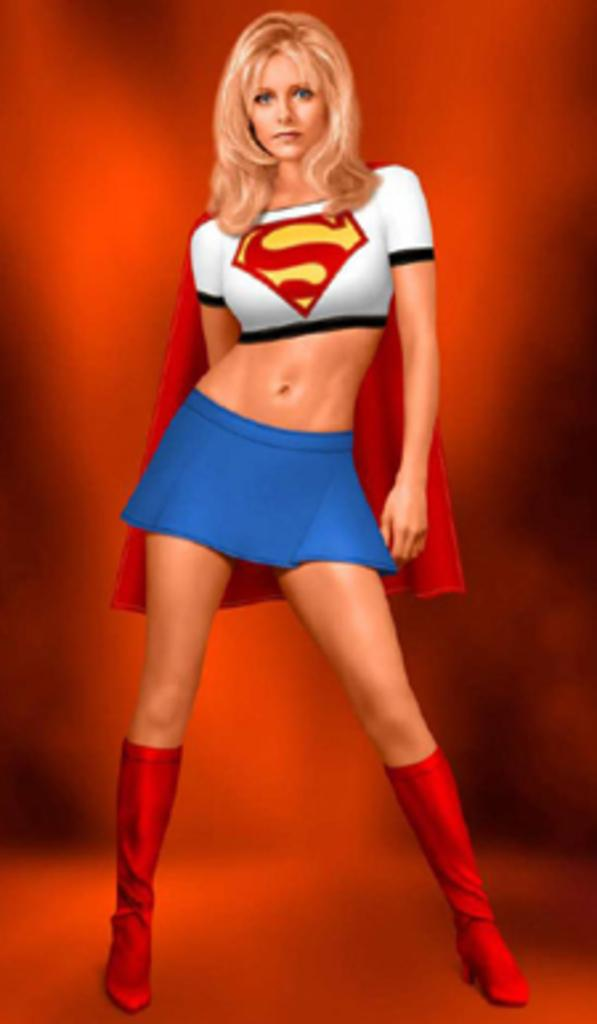What is the main subject of the image? There is a painting in the image. What is depicted in the painting? The painting depicts a woman. What is the woman wearing in the painting? The woman is wearing a superwoman dress in the painting. What type of sack is the woman carrying in the painting? There is no sack present in the painting; the woman is wearing a superwoman dress. What does the woman's dad think about her outfit in the painting? The provided facts do not mention the woman's dad or his opinion about her outfit. 